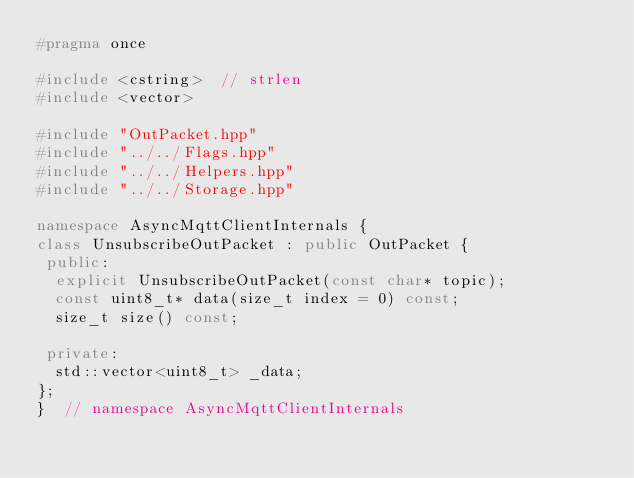<code> <loc_0><loc_0><loc_500><loc_500><_C++_>#pragma once

#include <cstring>  // strlen
#include <vector>

#include "OutPacket.hpp"
#include "../../Flags.hpp"
#include "../../Helpers.hpp"
#include "../../Storage.hpp"

namespace AsyncMqttClientInternals {
class UnsubscribeOutPacket : public OutPacket {
 public:
  explicit UnsubscribeOutPacket(const char* topic);
  const uint8_t* data(size_t index = 0) const;
  size_t size() const;

 private:
  std::vector<uint8_t> _data;
};
}  // namespace AsyncMqttClientInternals
</code> 